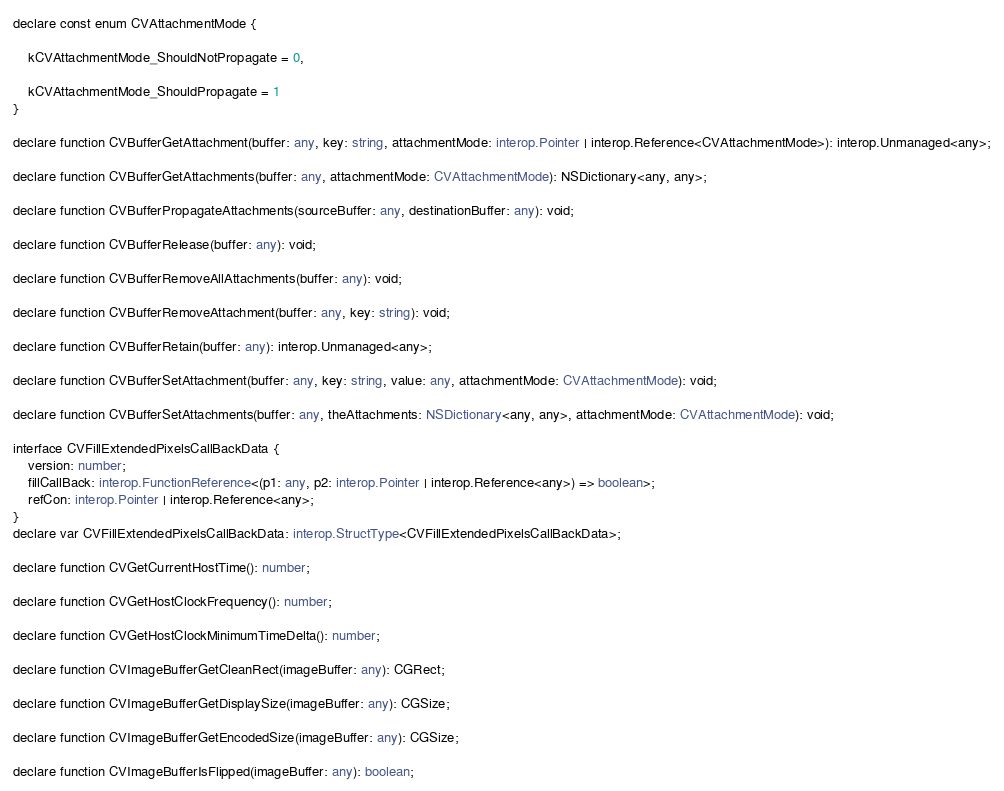<code> <loc_0><loc_0><loc_500><loc_500><_TypeScript_>
declare const enum CVAttachmentMode {

	kCVAttachmentMode_ShouldNotPropagate = 0,

	kCVAttachmentMode_ShouldPropagate = 1
}

declare function CVBufferGetAttachment(buffer: any, key: string, attachmentMode: interop.Pointer | interop.Reference<CVAttachmentMode>): interop.Unmanaged<any>;

declare function CVBufferGetAttachments(buffer: any, attachmentMode: CVAttachmentMode): NSDictionary<any, any>;

declare function CVBufferPropagateAttachments(sourceBuffer: any, destinationBuffer: any): void;

declare function CVBufferRelease(buffer: any): void;

declare function CVBufferRemoveAllAttachments(buffer: any): void;

declare function CVBufferRemoveAttachment(buffer: any, key: string): void;

declare function CVBufferRetain(buffer: any): interop.Unmanaged<any>;

declare function CVBufferSetAttachment(buffer: any, key: string, value: any, attachmentMode: CVAttachmentMode): void;

declare function CVBufferSetAttachments(buffer: any, theAttachments: NSDictionary<any, any>, attachmentMode: CVAttachmentMode): void;

interface CVFillExtendedPixelsCallBackData {
	version: number;
	fillCallBack: interop.FunctionReference<(p1: any, p2: interop.Pointer | interop.Reference<any>) => boolean>;
	refCon: interop.Pointer | interop.Reference<any>;
}
declare var CVFillExtendedPixelsCallBackData: interop.StructType<CVFillExtendedPixelsCallBackData>;

declare function CVGetCurrentHostTime(): number;

declare function CVGetHostClockFrequency(): number;

declare function CVGetHostClockMinimumTimeDelta(): number;

declare function CVImageBufferGetCleanRect(imageBuffer: any): CGRect;

declare function CVImageBufferGetDisplaySize(imageBuffer: any): CGSize;

declare function CVImageBufferGetEncodedSize(imageBuffer: any): CGSize;

declare function CVImageBufferIsFlipped(imageBuffer: any): boolean;
</code> 